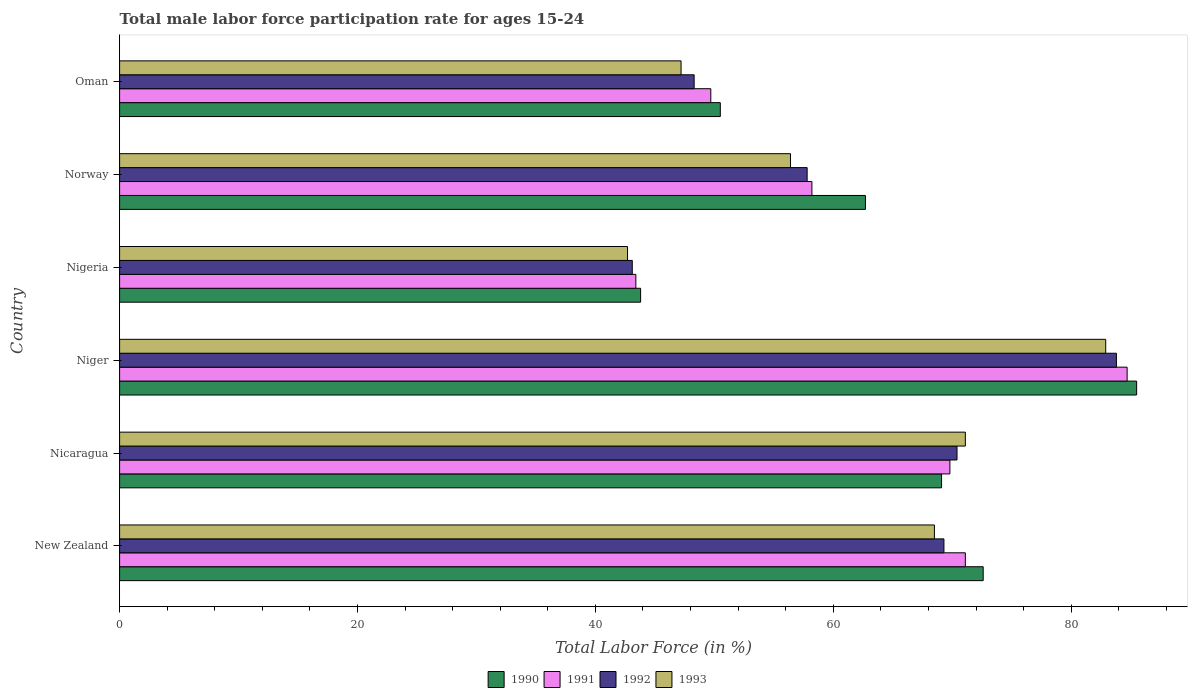How many different coloured bars are there?
Provide a succinct answer. 4. Are the number of bars on each tick of the Y-axis equal?
Provide a succinct answer. Yes. What is the male labor force participation rate in 1991 in Oman?
Ensure brevity in your answer.  49.7. Across all countries, what is the maximum male labor force participation rate in 1990?
Provide a short and direct response. 85.5. Across all countries, what is the minimum male labor force participation rate in 1992?
Your answer should be very brief. 43.1. In which country was the male labor force participation rate in 1991 maximum?
Provide a short and direct response. Niger. In which country was the male labor force participation rate in 1993 minimum?
Give a very brief answer. Nigeria. What is the total male labor force participation rate in 1993 in the graph?
Make the answer very short. 368.8. What is the difference between the male labor force participation rate in 1992 in Nicaragua and that in Oman?
Offer a terse response. 22.1. What is the difference between the male labor force participation rate in 1991 in Nigeria and the male labor force participation rate in 1992 in Niger?
Offer a very short reply. -40.4. What is the average male labor force participation rate in 1993 per country?
Ensure brevity in your answer.  61.47. In how many countries, is the male labor force participation rate in 1992 greater than 20 %?
Your answer should be very brief. 6. What is the ratio of the male labor force participation rate in 1991 in Niger to that in Nigeria?
Offer a terse response. 1.95. What is the difference between the highest and the second highest male labor force participation rate in 1992?
Your response must be concise. 13.4. What is the difference between the highest and the lowest male labor force participation rate in 1991?
Make the answer very short. 41.3. In how many countries, is the male labor force participation rate in 1993 greater than the average male labor force participation rate in 1993 taken over all countries?
Ensure brevity in your answer.  3. Is the sum of the male labor force participation rate in 1993 in New Zealand and Nigeria greater than the maximum male labor force participation rate in 1992 across all countries?
Make the answer very short. Yes. What does the 3rd bar from the top in New Zealand represents?
Offer a terse response. 1991. Is it the case that in every country, the sum of the male labor force participation rate in 1993 and male labor force participation rate in 1990 is greater than the male labor force participation rate in 1992?
Give a very brief answer. Yes. How many bars are there?
Provide a succinct answer. 24. Are all the bars in the graph horizontal?
Your answer should be very brief. Yes. Does the graph contain any zero values?
Provide a short and direct response. No. Where does the legend appear in the graph?
Your answer should be compact. Bottom center. How many legend labels are there?
Your answer should be compact. 4. How are the legend labels stacked?
Your answer should be compact. Horizontal. What is the title of the graph?
Offer a very short reply. Total male labor force participation rate for ages 15-24. Does "1976" appear as one of the legend labels in the graph?
Ensure brevity in your answer.  No. What is the label or title of the X-axis?
Your answer should be very brief. Total Labor Force (in %). What is the label or title of the Y-axis?
Offer a terse response. Country. What is the Total Labor Force (in %) in 1990 in New Zealand?
Offer a terse response. 72.6. What is the Total Labor Force (in %) of 1991 in New Zealand?
Your response must be concise. 71.1. What is the Total Labor Force (in %) of 1992 in New Zealand?
Ensure brevity in your answer.  69.3. What is the Total Labor Force (in %) of 1993 in New Zealand?
Offer a very short reply. 68.5. What is the Total Labor Force (in %) of 1990 in Nicaragua?
Give a very brief answer. 69.1. What is the Total Labor Force (in %) of 1991 in Nicaragua?
Your response must be concise. 69.8. What is the Total Labor Force (in %) of 1992 in Nicaragua?
Your answer should be compact. 70.4. What is the Total Labor Force (in %) of 1993 in Nicaragua?
Your answer should be very brief. 71.1. What is the Total Labor Force (in %) in 1990 in Niger?
Ensure brevity in your answer.  85.5. What is the Total Labor Force (in %) in 1991 in Niger?
Offer a very short reply. 84.7. What is the Total Labor Force (in %) of 1992 in Niger?
Make the answer very short. 83.8. What is the Total Labor Force (in %) of 1993 in Niger?
Give a very brief answer. 82.9. What is the Total Labor Force (in %) in 1990 in Nigeria?
Offer a very short reply. 43.8. What is the Total Labor Force (in %) of 1991 in Nigeria?
Your answer should be very brief. 43.4. What is the Total Labor Force (in %) of 1992 in Nigeria?
Offer a very short reply. 43.1. What is the Total Labor Force (in %) in 1993 in Nigeria?
Offer a terse response. 42.7. What is the Total Labor Force (in %) in 1990 in Norway?
Give a very brief answer. 62.7. What is the Total Labor Force (in %) in 1991 in Norway?
Make the answer very short. 58.2. What is the Total Labor Force (in %) of 1992 in Norway?
Your response must be concise. 57.8. What is the Total Labor Force (in %) of 1993 in Norway?
Provide a short and direct response. 56.4. What is the Total Labor Force (in %) in 1990 in Oman?
Keep it short and to the point. 50.5. What is the Total Labor Force (in %) of 1991 in Oman?
Ensure brevity in your answer.  49.7. What is the Total Labor Force (in %) in 1992 in Oman?
Ensure brevity in your answer.  48.3. What is the Total Labor Force (in %) in 1993 in Oman?
Your answer should be very brief. 47.2. Across all countries, what is the maximum Total Labor Force (in %) of 1990?
Give a very brief answer. 85.5. Across all countries, what is the maximum Total Labor Force (in %) in 1991?
Provide a succinct answer. 84.7. Across all countries, what is the maximum Total Labor Force (in %) of 1992?
Provide a short and direct response. 83.8. Across all countries, what is the maximum Total Labor Force (in %) in 1993?
Keep it short and to the point. 82.9. Across all countries, what is the minimum Total Labor Force (in %) in 1990?
Offer a terse response. 43.8. Across all countries, what is the minimum Total Labor Force (in %) in 1991?
Make the answer very short. 43.4. Across all countries, what is the minimum Total Labor Force (in %) in 1992?
Offer a terse response. 43.1. Across all countries, what is the minimum Total Labor Force (in %) of 1993?
Offer a very short reply. 42.7. What is the total Total Labor Force (in %) in 1990 in the graph?
Your response must be concise. 384.2. What is the total Total Labor Force (in %) in 1991 in the graph?
Your response must be concise. 376.9. What is the total Total Labor Force (in %) of 1992 in the graph?
Provide a short and direct response. 372.7. What is the total Total Labor Force (in %) of 1993 in the graph?
Offer a terse response. 368.8. What is the difference between the Total Labor Force (in %) in 1990 in New Zealand and that in Nicaragua?
Ensure brevity in your answer.  3.5. What is the difference between the Total Labor Force (in %) in 1991 in New Zealand and that in Nicaragua?
Your answer should be very brief. 1.3. What is the difference between the Total Labor Force (in %) in 1993 in New Zealand and that in Nicaragua?
Offer a terse response. -2.6. What is the difference between the Total Labor Force (in %) of 1991 in New Zealand and that in Niger?
Offer a very short reply. -13.6. What is the difference between the Total Labor Force (in %) in 1993 in New Zealand and that in Niger?
Your response must be concise. -14.4. What is the difference between the Total Labor Force (in %) of 1990 in New Zealand and that in Nigeria?
Offer a very short reply. 28.8. What is the difference between the Total Labor Force (in %) of 1991 in New Zealand and that in Nigeria?
Keep it short and to the point. 27.7. What is the difference between the Total Labor Force (in %) in 1992 in New Zealand and that in Nigeria?
Your answer should be compact. 26.2. What is the difference between the Total Labor Force (in %) of 1993 in New Zealand and that in Nigeria?
Your response must be concise. 25.8. What is the difference between the Total Labor Force (in %) in 1990 in New Zealand and that in Norway?
Make the answer very short. 9.9. What is the difference between the Total Labor Force (in %) of 1991 in New Zealand and that in Norway?
Give a very brief answer. 12.9. What is the difference between the Total Labor Force (in %) in 1992 in New Zealand and that in Norway?
Ensure brevity in your answer.  11.5. What is the difference between the Total Labor Force (in %) in 1990 in New Zealand and that in Oman?
Provide a short and direct response. 22.1. What is the difference between the Total Labor Force (in %) of 1991 in New Zealand and that in Oman?
Provide a short and direct response. 21.4. What is the difference between the Total Labor Force (in %) in 1993 in New Zealand and that in Oman?
Your answer should be very brief. 21.3. What is the difference between the Total Labor Force (in %) in 1990 in Nicaragua and that in Niger?
Your response must be concise. -16.4. What is the difference between the Total Labor Force (in %) of 1991 in Nicaragua and that in Niger?
Make the answer very short. -14.9. What is the difference between the Total Labor Force (in %) of 1992 in Nicaragua and that in Niger?
Give a very brief answer. -13.4. What is the difference between the Total Labor Force (in %) of 1993 in Nicaragua and that in Niger?
Ensure brevity in your answer.  -11.8. What is the difference between the Total Labor Force (in %) in 1990 in Nicaragua and that in Nigeria?
Offer a terse response. 25.3. What is the difference between the Total Labor Force (in %) of 1991 in Nicaragua and that in Nigeria?
Ensure brevity in your answer.  26.4. What is the difference between the Total Labor Force (in %) of 1992 in Nicaragua and that in Nigeria?
Keep it short and to the point. 27.3. What is the difference between the Total Labor Force (in %) of 1993 in Nicaragua and that in Nigeria?
Make the answer very short. 28.4. What is the difference between the Total Labor Force (in %) of 1990 in Nicaragua and that in Norway?
Your response must be concise. 6.4. What is the difference between the Total Labor Force (in %) of 1991 in Nicaragua and that in Norway?
Give a very brief answer. 11.6. What is the difference between the Total Labor Force (in %) in 1991 in Nicaragua and that in Oman?
Provide a short and direct response. 20.1. What is the difference between the Total Labor Force (in %) in 1992 in Nicaragua and that in Oman?
Your response must be concise. 22.1. What is the difference between the Total Labor Force (in %) of 1993 in Nicaragua and that in Oman?
Your answer should be compact. 23.9. What is the difference between the Total Labor Force (in %) of 1990 in Niger and that in Nigeria?
Ensure brevity in your answer.  41.7. What is the difference between the Total Labor Force (in %) of 1991 in Niger and that in Nigeria?
Your response must be concise. 41.3. What is the difference between the Total Labor Force (in %) in 1992 in Niger and that in Nigeria?
Keep it short and to the point. 40.7. What is the difference between the Total Labor Force (in %) in 1993 in Niger and that in Nigeria?
Your answer should be very brief. 40.2. What is the difference between the Total Labor Force (in %) of 1990 in Niger and that in Norway?
Provide a succinct answer. 22.8. What is the difference between the Total Labor Force (in %) in 1993 in Niger and that in Norway?
Ensure brevity in your answer.  26.5. What is the difference between the Total Labor Force (in %) in 1990 in Niger and that in Oman?
Ensure brevity in your answer.  35. What is the difference between the Total Labor Force (in %) of 1991 in Niger and that in Oman?
Your answer should be very brief. 35. What is the difference between the Total Labor Force (in %) in 1992 in Niger and that in Oman?
Provide a succinct answer. 35.5. What is the difference between the Total Labor Force (in %) of 1993 in Niger and that in Oman?
Give a very brief answer. 35.7. What is the difference between the Total Labor Force (in %) of 1990 in Nigeria and that in Norway?
Ensure brevity in your answer.  -18.9. What is the difference between the Total Labor Force (in %) in 1991 in Nigeria and that in Norway?
Your response must be concise. -14.8. What is the difference between the Total Labor Force (in %) of 1992 in Nigeria and that in Norway?
Provide a short and direct response. -14.7. What is the difference between the Total Labor Force (in %) of 1993 in Nigeria and that in Norway?
Your answer should be compact. -13.7. What is the difference between the Total Labor Force (in %) of 1992 in Nigeria and that in Oman?
Offer a terse response. -5.2. What is the difference between the Total Labor Force (in %) in 1993 in Nigeria and that in Oman?
Provide a short and direct response. -4.5. What is the difference between the Total Labor Force (in %) of 1992 in Norway and that in Oman?
Your answer should be very brief. 9.5. What is the difference between the Total Labor Force (in %) of 1990 in New Zealand and the Total Labor Force (in %) of 1991 in Nicaragua?
Make the answer very short. 2.8. What is the difference between the Total Labor Force (in %) of 1990 in New Zealand and the Total Labor Force (in %) of 1992 in Nicaragua?
Provide a short and direct response. 2.2. What is the difference between the Total Labor Force (in %) of 1991 in New Zealand and the Total Labor Force (in %) of 1992 in Nicaragua?
Provide a short and direct response. 0.7. What is the difference between the Total Labor Force (in %) of 1991 in New Zealand and the Total Labor Force (in %) of 1993 in Nicaragua?
Offer a very short reply. 0. What is the difference between the Total Labor Force (in %) in 1990 in New Zealand and the Total Labor Force (in %) in 1993 in Niger?
Your answer should be compact. -10.3. What is the difference between the Total Labor Force (in %) in 1991 in New Zealand and the Total Labor Force (in %) in 1992 in Niger?
Offer a very short reply. -12.7. What is the difference between the Total Labor Force (in %) of 1992 in New Zealand and the Total Labor Force (in %) of 1993 in Niger?
Your response must be concise. -13.6. What is the difference between the Total Labor Force (in %) of 1990 in New Zealand and the Total Labor Force (in %) of 1991 in Nigeria?
Make the answer very short. 29.2. What is the difference between the Total Labor Force (in %) in 1990 in New Zealand and the Total Labor Force (in %) in 1992 in Nigeria?
Offer a very short reply. 29.5. What is the difference between the Total Labor Force (in %) of 1990 in New Zealand and the Total Labor Force (in %) of 1993 in Nigeria?
Your answer should be compact. 29.9. What is the difference between the Total Labor Force (in %) in 1991 in New Zealand and the Total Labor Force (in %) in 1992 in Nigeria?
Offer a very short reply. 28. What is the difference between the Total Labor Force (in %) of 1991 in New Zealand and the Total Labor Force (in %) of 1993 in Nigeria?
Your answer should be compact. 28.4. What is the difference between the Total Labor Force (in %) of 1992 in New Zealand and the Total Labor Force (in %) of 1993 in Nigeria?
Offer a terse response. 26.6. What is the difference between the Total Labor Force (in %) of 1990 in New Zealand and the Total Labor Force (in %) of 1992 in Norway?
Offer a very short reply. 14.8. What is the difference between the Total Labor Force (in %) in 1992 in New Zealand and the Total Labor Force (in %) in 1993 in Norway?
Make the answer very short. 12.9. What is the difference between the Total Labor Force (in %) of 1990 in New Zealand and the Total Labor Force (in %) of 1991 in Oman?
Keep it short and to the point. 22.9. What is the difference between the Total Labor Force (in %) in 1990 in New Zealand and the Total Labor Force (in %) in 1992 in Oman?
Offer a terse response. 24.3. What is the difference between the Total Labor Force (in %) of 1990 in New Zealand and the Total Labor Force (in %) of 1993 in Oman?
Provide a succinct answer. 25.4. What is the difference between the Total Labor Force (in %) of 1991 in New Zealand and the Total Labor Force (in %) of 1992 in Oman?
Keep it short and to the point. 22.8. What is the difference between the Total Labor Force (in %) in 1991 in New Zealand and the Total Labor Force (in %) in 1993 in Oman?
Keep it short and to the point. 23.9. What is the difference between the Total Labor Force (in %) of 1992 in New Zealand and the Total Labor Force (in %) of 1993 in Oman?
Give a very brief answer. 22.1. What is the difference between the Total Labor Force (in %) of 1990 in Nicaragua and the Total Labor Force (in %) of 1991 in Niger?
Keep it short and to the point. -15.6. What is the difference between the Total Labor Force (in %) of 1990 in Nicaragua and the Total Labor Force (in %) of 1992 in Niger?
Keep it short and to the point. -14.7. What is the difference between the Total Labor Force (in %) in 1992 in Nicaragua and the Total Labor Force (in %) in 1993 in Niger?
Your response must be concise. -12.5. What is the difference between the Total Labor Force (in %) of 1990 in Nicaragua and the Total Labor Force (in %) of 1991 in Nigeria?
Offer a very short reply. 25.7. What is the difference between the Total Labor Force (in %) of 1990 in Nicaragua and the Total Labor Force (in %) of 1993 in Nigeria?
Your answer should be very brief. 26.4. What is the difference between the Total Labor Force (in %) of 1991 in Nicaragua and the Total Labor Force (in %) of 1992 in Nigeria?
Keep it short and to the point. 26.7. What is the difference between the Total Labor Force (in %) of 1991 in Nicaragua and the Total Labor Force (in %) of 1993 in Nigeria?
Give a very brief answer. 27.1. What is the difference between the Total Labor Force (in %) in 1992 in Nicaragua and the Total Labor Force (in %) in 1993 in Nigeria?
Offer a very short reply. 27.7. What is the difference between the Total Labor Force (in %) of 1990 in Nicaragua and the Total Labor Force (in %) of 1991 in Norway?
Your answer should be very brief. 10.9. What is the difference between the Total Labor Force (in %) in 1990 in Nicaragua and the Total Labor Force (in %) in 1992 in Norway?
Offer a terse response. 11.3. What is the difference between the Total Labor Force (in %) in 1990 in Nicaragua and the Total Labor Force (in %) in 1993 in Norway?
Give a very brief answer. 12.7. What is the difference between the Total Labor Force (in %) in 1991 in Nicaragua and the Total Labor Force (in %) in 1992 in Norway?
Give a very brief answer. 12. What is the difference between the Total Labor Force (in %) in 1991 in Nicaragua and the Total Labor Force (in %) in 1993 in Norway?
Make the answer very short. 13.4. What is the difference between the Total Labor Force (in %) in 1990 in Nicaragua and the Total Labor Force (in %) in 1992 in Oman?
Your answer should be very brief. 20.8. What is the difference between the Total Labor Force (in %) of 1990 in Nicaragua and the Total Labor Force (in %) of 1993 in Oman?
Your response must be concise. 21.9. What is the difference between the Total Labor Force (in %) in 1991 in Nicaragua and the Total Labor Force (in %) in 1992 in Oman?
Provide a succinct answer. 21.5. What is the difference between the Total Labor Force (in %) of 1991 in Nicaragua and the Total Labor Force (in %) of 1993 in Oman?
Keep it short and to the point. 22.6. What is the difference between the Total Labor Force (in %) of 1992 in Nicaragua and the Total Labor Force (in %) of 1993 in Oman?
Offer a very short reply. 23.2. What is the difference between the Total Labor Force (in %) in 1990 in Niger and the Total Labor Force (in %) in 1991 in Nigeria?
Provide a short and direct response. 42.1. What is the difference between the Total Labor Force (in %) in 1990 in Niger and the Total Labor Force (in %) in 1992 in Nigeria?
Provide a succinct answer. 42.4. What is the difference between the Total Labor Force (in %) of 1990 in Niger and the Total Labor Force (in %) of 1993 in Nigeria?
Provide a short and direct response. 42.8. What is the difference between the Total Labor Force (in %) of 1991 in Niger and the Total Labor Force (in %) of 1992 in Nigeria?
Provide a short and direct response. 41.6. What is the difference between the Total Labor Force (in %) in 1991 in Niger and the Total Labor Force (in %) in 1993 in Nigeria?
Keep it short and to the point. 42. What is the difference between the Total Labor Force (in %) in 1992 in Niger and the Total Labor Force (in %) in 1993 in Nigeria?
Provide a short and direct response. 41.1. What is the difference between the Total Labor Force (in %) in 1990 in Niger and the Total Labor Force (in %) in 1991 in Norway?
Your answer should be very brief. 27.3. What is the difference between the Total Labor Force (in %) in 1990 in Niger and the Total Labor Force (in %) in 1992 in Norway?
Your answer should be very brief. 27.7. What is the difference between the Total Labor Force (in %) of 1990 in Niger and the Total Labor Force (in %) of 1993 in Norway?
Ensure brevity in your answer.  29.1. What is the difference between the Total Labor Force (in %) in 1991 in Niger and the Total Labor Force (in %) in 1992 in Norway?
Give a very brief answer. 26.9. What is the difference between the Total Labor Force (in %) of 1991 in Niger and the Total Labor Force (in %) of 1993 in Norway?
Offer a very short reply. 28.3. What is the difference between the Total Labor Force (in %) of 1992 in Niger and the Total Labor Force (in %) of 1993 in Norway?
Your response must be concise. 27.4. What is the difference between the Total Labor Force (in %) of 1990 in Niger and the Total Labor Force (in %) of 1991 in Oman?
Your answer should be very brief. 35.8. What is the difference between the Total Labor Force (in %) in 1990 in Niger and the Total Labor Force (in %) in 1992 in Oman?
Offer a terse response. 37.2. What is the difference between the Total Labor Force (in %) in 1990 in Niger and the Total Labor Force (in %) in 1993 in Oman?
Offer a terse response. 38.3. What is the difference between the Total Labor Force (in %) in 1991 in Niger and the Total Labor Force (in %) in 1992 in Oman?
Provide a succinct answer. 36.4. What is the difference between the Total Labor Force (in %) in 1991 in Niger and the Total Labor Force (in %) in 1993 in Oman?
Provide a short and direct response. 37.5. What is the difference between the Total Labor Force (in %) in 1992 in Niger and the Total Labor Force (in %) in 1993 in Oman?
Offer a very short reply. 36.6. What is the difference between the Total Labor Force (in %) in 1990 in Nigeria and the Total Labor Force (in %) in 1991 in Norway?
Your answer should be very brief. -14.4. What is the difference between the Total Labor Force (in %) of 1991 in Nigeria and the Total Labor Force (in %) of 1992 in Norway?
Provide a short and direct response. -14.4. What is the difference between the Total Labor Force (in %) of 1990 in Nigeria and the Total Labor Force (in %) of 1991 in Oman?
Your answer should be very brief. -5.9. What is the difference between the Total Labor Force (in %) in 1990 in Nigeria and the Total Labor Force (in %) in 1992 in Oman?
Give a very brief answer. -4.5. What is the difference between the Total Labor Force (in %) of 1991 in Nigeria and the Total Labor Force (in %) of 1993 in Oman?
Your answer should be very brief. -3.8. What is the difference between the Total Labor Force (in %) of 1992 in Nigeria and the Total Labor Force (in %) of 1993 in Oman?
Your response must be concise. -4.1. What is the difference between the Total Labor Force (in %) of 1990 in Norway and the Total Labor Force (in %) of 1991 in Oman?
Provide a short and direct response. 13. What is the difference between the Total Labor Force (in %) of 1990 in Norway and the Total Labor Force (in %) of 1992 in Oman?
Make the answer very short. 14.4. What is the difference between the Total Labor Force (in %) in 1991 in Norway and the Total Labor Force (in %) in 1992 in Oman?
Provide a succinct answer. 9.9. What is the difference between the Total Labor Force (in %) in 1991 in Norway and the Total Labor Force (in %) in 1993 in Oman?
Your answer should be compact. 11. What is the average Total Labor Force (in %) in 1990 per country?
Offer a terse response. 64.03. What is the average Total Labor Force (in %) of 1991 per country?
Offer a very short reply. 62.82. What is the average Total Labor Force (in %) of 1992 per country?
Your answer should be compact. 62.12. What is the average Total Labor Force (in %) of 1993 per country?
Give a very brief answer. 61.47. What is the difference between the Total Labor Force (in %) of 1990 and Total Labor Force (in %) of 1992 in New Zealand?
Offer a terse response. 3.3. What is the difference between the Total Labor Force (in %) of 1990 and Total Labor Force (in %) of 1991 in Nicaragua?
Provide a short and direct response. -0.7. What is the difference between the Total Labor Force (in %) of 1990 and Total Labor Force (in %) of 1992 in Nicaragua?
Offer a very short reply. -1.3. What is the difference between the Total Labor Force (in %) of 1992 and Total Labor Force (in %) of 1993 in Nicaragua?
Your answer should be compact. -0.7. What is the difference between the Total Labor Force (in %) of 1990 and Total Labor Force (in %) of 1992 in Niger?
Offer a terse response. 1.7. What is the difference between the Total Labor Force (in %) in 1991 and Total Labor Force (in %) in 1993 in Niger?
Make the answer very short. 1.8. What is the difference between the Total Labor Force (in %) in 1990 and Total Labor Force (in %) in 1993 in Nigeria?
Your answer should be very brief. 1.1. What is the difference between the Total Labor Force (in %) in 1991 and Total Labor Force (in %) in 1992 in Nigeria?
Your answer should be very brief. 0.3. What is the difference between the Total Labor Force (in %) in 1991 and Total Labor Force (in %) in 1993 in Nigeria?
Keep it short and to the point. 0.7. What is the difference between the Total Labor Force (in %) of 1990 and Total Labor Force (in %) of 1993 in Norway?
Give a very brief answer. 6.3. What is the difference between the Total Labor Force (in %) in 1991 and Total Labor Force (in %) in 1992 in Norway?
Your answer should be compact. 0.4. What is the difference between the Total Labor Force (in %) of 1992 and Total Labor Force (in %) of 1993 in Norway?
Your answer should be compact. 1.4. What is the difference between the Total Labor Force (in %) of 1990 and Total Labor Force (in %) of 1992 in Oman?
Ensure brevity in your answer.  2.2. What is the difference between the Total Labor Force (in %) in 1990 and Total Labor Force (in %) in 1993 in Oman?
Keep it short and to the point. 3.3. What is the difference between the Total Labor Force (in %) of 1991 and Total Labor Force (in %) of 1993 in Oman?
Give a very brief answer. 2.5. What is the ratio of the Total Labor Force (in %) in 1990 in New Zealand to that in Nicaragua?
Ensure brevity in your answer.  1.05. What is the ratio of the Total Labor Force (in %) in 1991 in New Zealand to that in Nicaragua?
Your response must be concise. 1.02. What is the ratio of the Total Labor Force (in %) in 1992 in New Zealand to that in Nicaragua?
Your answer should be very brief. 0.98. What is the ratio of the Total Labor Force (in %) in 1993 in New Zealand to that in Nicaragua?
Your response must be concise. 0.96. What is the ratio of the Total Labor Force (in %) of 1990 in New Zealand to that in Niger?
Provide a short and direct response. 0.85. What is the ratio of the Total Labor Force (in %) of 1991 in New Zealand to that in Niger?
Keep it short and to the point. 0.84. What is the ratio of the Total Labor Force (in %) of 1992 in New Zealand to that in Niger?
Your response must be concise. 0.83. What is the ratio of the Total Labor Force (in %) in 1993 in New Zealand to that in Niger?
Your answer should be compact. 0.83. What is the ratio of the Total Labor Force (in %) in 1990 in New Zealand to that in Nigeria?
Make the answer very short. 1.66. What is the ratio of the Total Labor Force (in %) in 1991 in New Zealand to that in Nigeria?
Make the answer very short. 1.64. What is the ratio of the Total Labor Force (in %) of 1992 in New Zealand to that in Nigeria?
Make the answer very short. 1.61. What is the ratio of the Total Labor Force (in %) in 1993 in New Zealand to that in Nigeria?
Give a very brief answer. 1.6. What is the ratio of the Total Labor Force (in %) in 1990 in New Zealand to that in Norway?
Ensure brevity in your answer.  1.16. What is the ratio of the Total Labor Force (in %) in 1991 in New Zealand to that in Norway?
Offer a very short reply. 1.22. What is the ratio of the Total Labor Force (in %) in 1992 in New Zealand to that in Norway?
Your answer should be compact. 1.2. What is the ratio of the Total Labor Force (in %) of 1993 in New Zealand to that in Norway?
Your answer should be compact. 1.21. What is the ratio of the Total Labor Force (in %) of 1990 in New Zealand to that in Oman?
Make the answer very short. 1.44. What is the ratio of the Total Labor Force (in %) in 1991 in New Zealand to that in Oman?
Ensure brevity in your answer.  1.43. What is the ratio of the Total Labor Force (in %) of 1992 in New Zealand to that in Oman?
Make the answer very short. 1.43. What is the ratio of the Total Labor Force (in %) in 1993 in New Zealand to that in Oman?
Give a very brief answer. 1.45. What is the ratio of the Total Labor Force (in %) in 1990 in Nicaragua to that in Niger?
Keep it short and to the point. 0.81. What is the ratio of the Total Labor Force (in %) of 1991 in Nicaragua to that in Niger?
Provide a succinct answer. 0.82. What is the ratio of the Total Labor Force (in %) in 1992 in Nicaragua to that in Niger?
Your answer should be compact. 0.84. What is the ratio of the Total Labor Force (in %) of 1993 in Nicaragua to that in Niger?
Offer a very short reply. 0.86. What is the ratio of the Total Labor Force (in %) in 1990 in Nicaragua to that in Nigeria?
Your response must be concise. 1.58. What is the ratio of the Total Labor Force (in %) in 1991 in Nicaragua to that in Nigeria?
Give a very brief answer. 1.61. What is the ratio of the Total Labor Force (in %) of 1992 in Nicaragua to that in Nigeria?
Make the answer very short. 1.63. What is the ratio of the Total Labor Force (in %) in 1993 in Nicaragua to that in Nigeria?
Keep it short and to the point. 1.67. What is the ratio of the Total Labor Force (in %) in 1990 in Nicaragua to that in Norway?
Make the answer very short. 1.1. What is the ratio of the Total Labor Force (in %) in 1991 in Nicaragua to that in Norway?
Your response must be concise. 1.2. What is the ratio of the Total Labor Force (in %) in 1992 in Nicaragua to that in Norway?
Offer a terse response. 1.22. What is the ratio of the Total Labor Force (in %) in 1993 in Nicaragua to that in Norway?
Offer a terse response. 1.26. What is the ratio of the Total Labor Force (in %) in 1990 in Nicaragua to that in Oman?
Give a very brief answer. 1.37. What is the ratio of the Total Labor Force (in %) of 1991 in Nicaragua to that in Oman?
Your answer should be compact. 1.4. What is the ratio of the Total Labor Force (in %) of 1992 in Nicaragua to that in Oman?
Offer a terse response. 1.46. What is the ratio of the Total Labor Force (in %) in 1993 in Nicaragua to that in Oman?
Offer a very short reply. 1.51. What is the ratio of the Total Labor Force (in %) of 1990 in Niger to that in Nigeria?
Your answer should be very brief. 1.95. What is the ratio of the Total Labor Force (in %) in 1991 in Niger to that in Nigeria?
Your answer should be very brief. 1.95. What is the ratio of the Total Labor Force (in %) of 1992 in Niger to that in Nigeria?
Offer a terse response. 1.94. What is the ratio of the Total Labor Force (in %) in 1993 in Niger to that in Nigeria?
Provide a short and direct response. 1.94. What is the ratio of the Total Labor Force (in %) in 1990 in Niger to that in Norway?
Give a very brief answer. 1.36. What is the ratio of the Total Labor Force (in %) of 1991 in Niger to that in Norway?
Your answer should be very brief. 1.46. What is the ratio of the Total Labor Force (in %) of 1992 in Niger to that in Norway?
Provide a short and direct response. 1.45. What is the ratio of the Total Labor Force (in %) in 1993 in Niger to that in Norway?
Keep it short and to the point. 1.47. What is the ratio of the Total Labor Force (in %) in 1990 in Niger to that in Oman?
Keep it short and to the point. 1.69. What is the ratio of the Total Labor Force (in %) in 1991 in Niger to that in Oman?
Your response must be concise. 1.7. What is the ratio of the Total Labor Force (in %) in 1992 in Niger to that in Oman?
Ensure brevity in your answer.  1.74. What is the ratio of the Total Labor Force (in %) in 1993 in Niger to that in Oman?
Your answer should be compact. 1.76. What is the ratio of the Total Labor Force (in %) of 1990 in Nigeria to that in Norway?
Your response must be concise. 0.7. What is the ratio of the Total Labor Force (in %) of 1991 in Nigeria to that in Norway?
Offer a terse response. 0.75. What is the ratio of the Total Labor Force (in %) in 1992 in Nigeria to that in Norway?
Keep it short and to the point. 0.75. What is the ratio of the Total Labor Force (in %) of 1993 in Nigeria to that in Norway?
Ensure brevity in your answer.  0.76. What is the ratio of the Total Labor Force (in %) in 1990 in Nigeria to that in Oman?
Your answer should be very brief. 0.87. What is the ratio of the Total Labor Force (in %) in 1991 in Nigeria to that in Oman?
Keep it short and to the point. 0.87. What is the ratio of the Total Labor Force (in %) in 1992 in Nigeria to that in Oman?
Offer a very short reply. 0.89. What is the ratio of the Total Labor Force (in %) of 1993 in Nigeria to that in Oman?
Give a very brief answer. 0.9. What is the ratio of the Total Labor Force (in %) in 1990 in Norway to that in Oman?
Your answer should be very brief. 1.24. What is the ratio of the Total Labor Force (in %) in 1991 in Norway to that in Oman?
Your answer should be compact. 1.17. What is the ratio of the Total Labor Force (in %) of 1992 in Norway to that in Oman?
Provide a short and direct response. 1.2. What is the ratio of the Total Labor Force (in %) in 1993 in Norway to that in Oman?
Your answer should be very brief. 1.19. What is the difference between the highest and the second highest Total Labor Force (in %) in 1991?
Your response must be concise. 13.6. What is the difference between the highest and the second highest Total Labor Force (in %) of 1992?
Your answer should be compact. 13.4. What is the difference between the highest and the lowest Total Labor Force (in %) of 1990?
Make the answer very short. 41.7. What is the difference between the highest and the lowest Total Labor Force (in %) in 1991?
Give a very brief answer. 41.3. What is the difference between the highest and the lowest Total Labor Force (in %) in 1992?
Offer a very short reply. 40.7. What is the difference between the highest and the lowest Total Labor Force (in %) in 1993?
Make the answer very short. 40.2. 